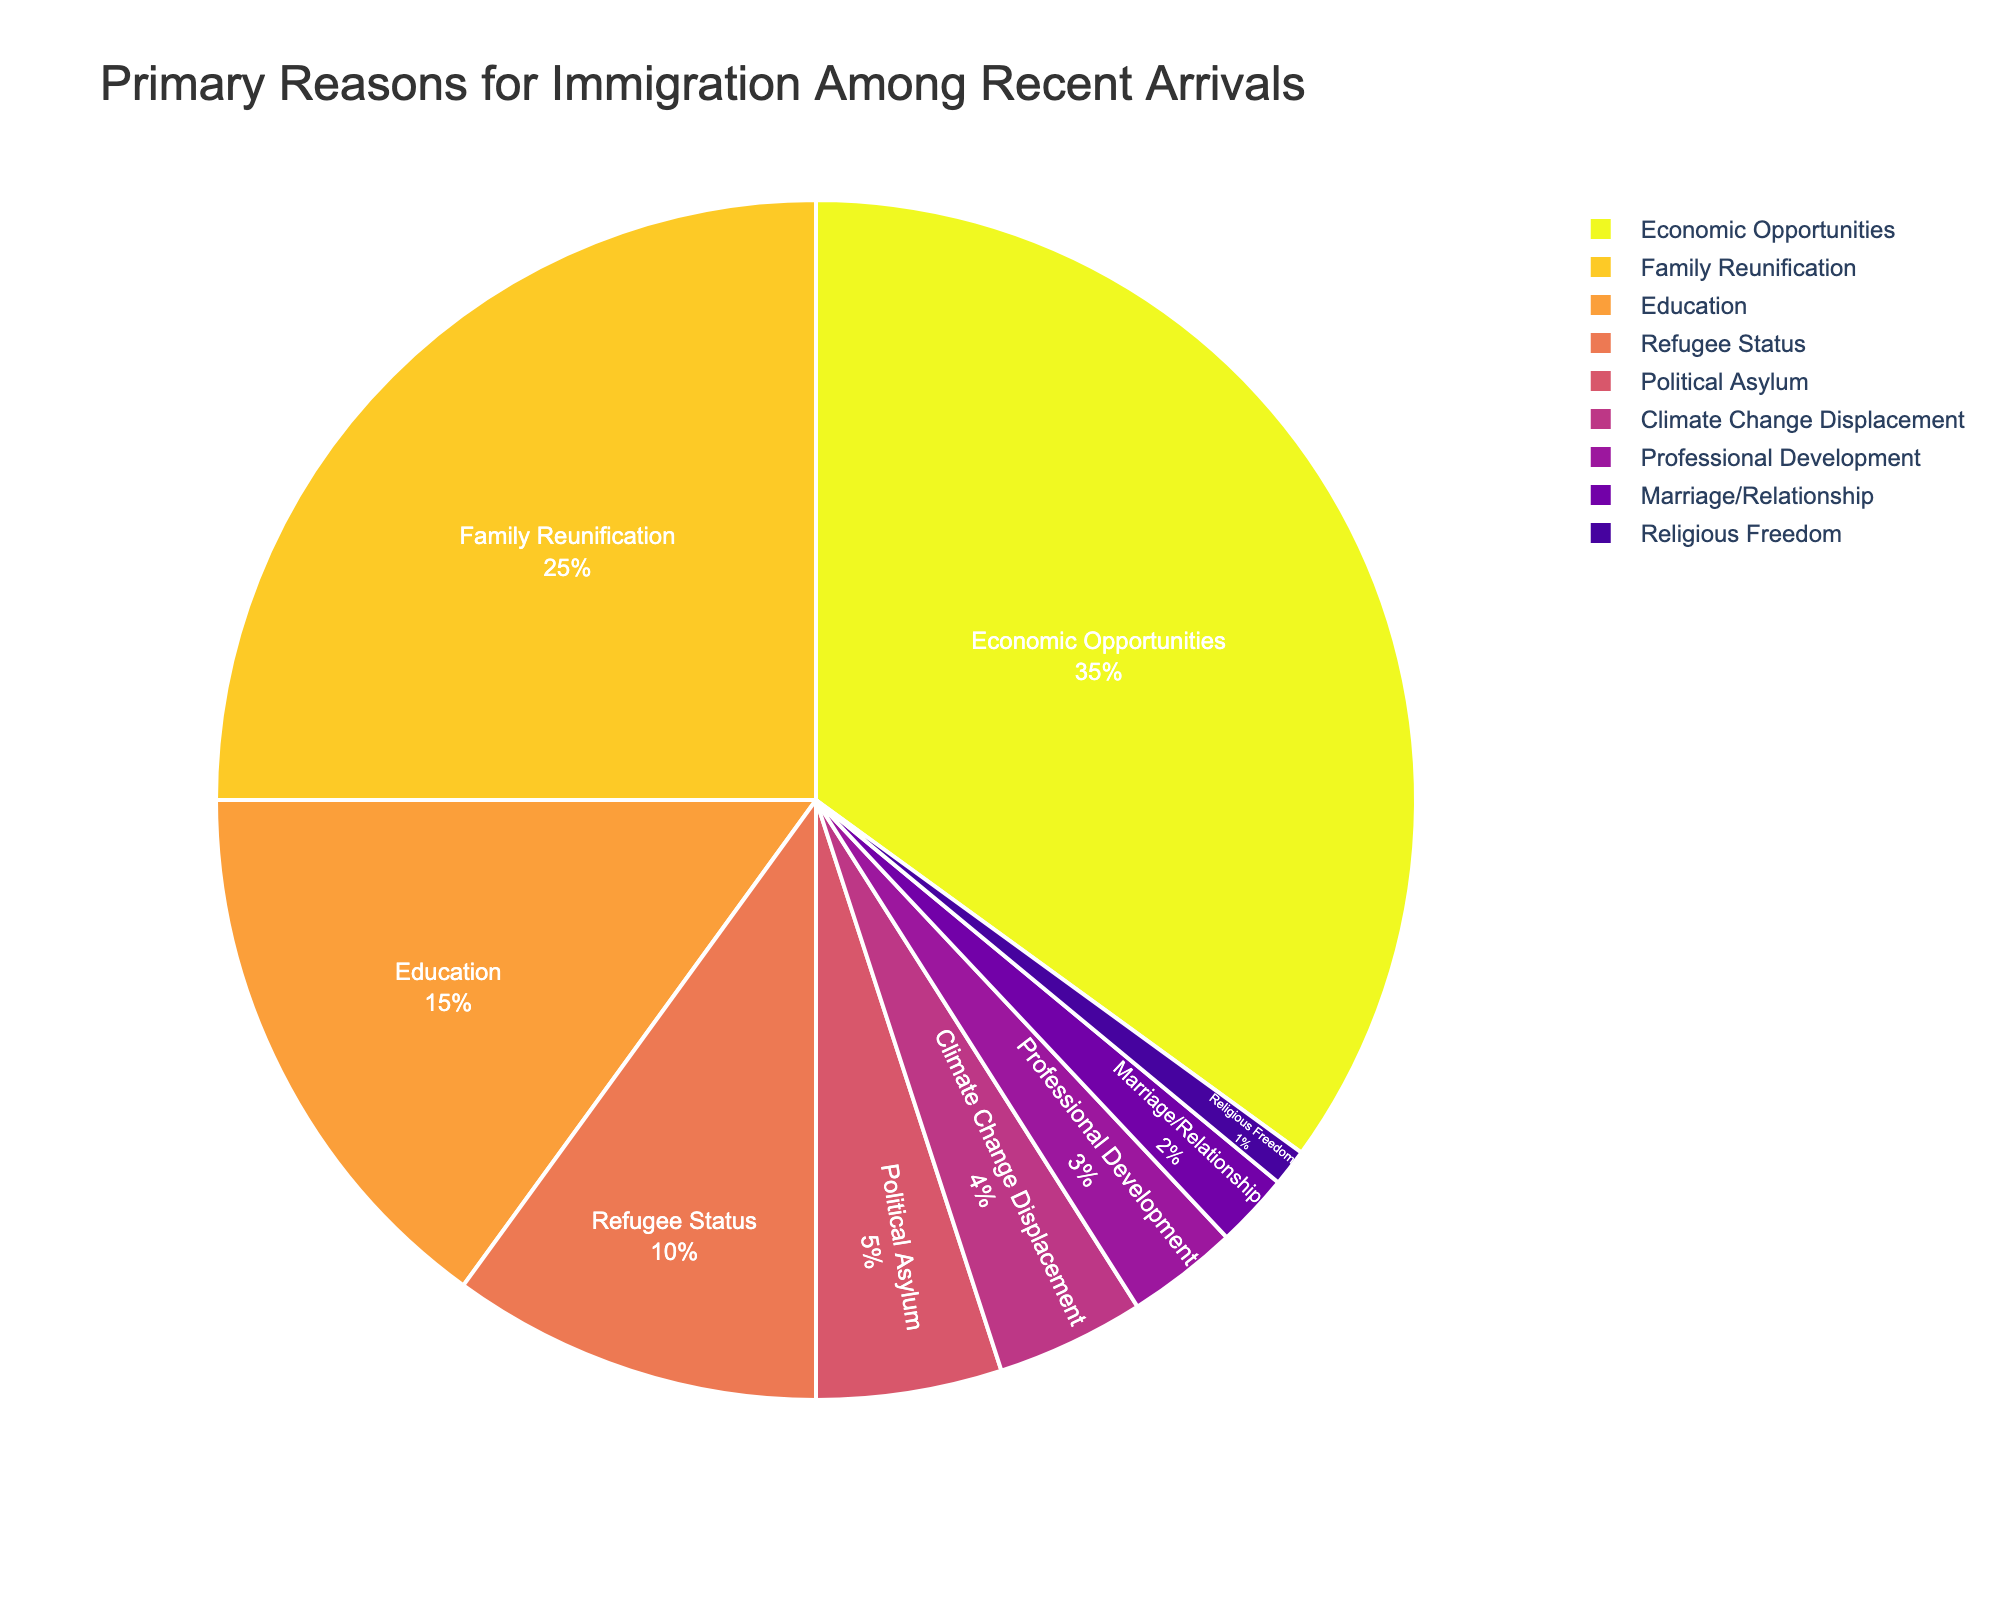What is the primary reason for immigration according to the pie chart? The largest slice of the pie chart represents the primary reason. "Economic Opportunities," which accounts for 35% of the total, is the largest slice.
Answer: Economic Opportunities Which category contributes more to immigration: Family Reunification or Refugee Status? Compare the percentages for both categories. "Family Reunification" is 25%, and "Refugee Status" is 10%. Since 25% is greater than 10%, Family Reunification contributes more.
Answer: Family Reunification What is the total percentage of immigrants arriving due to educational and professional reasons (Education and Professional Development)? Add the percentages of the "Education" and "Professional Development" slices: 15% + 3% = 18%.
Answer: 18% Which category has the smallest percentage representation and what is that percentage? The smallest slice in the pie chart represents "Religious Freedom" with 1% of the total.
Answer: Religious Freedom, 1% How much more significant is Economic Opportunities as a reason for immigration compared to Climate Change Displacement? Subtract the percentage of "Climate Change Displacement" (4%) from "Economic Opportunities" (35%): 35% - 4% = 31%.
Answer: 31% Which category is represented by a proportion visually similar to 10%? The slice labeled "Refugee Status" represents 10% of the total.
Answer: Refugee Status If the percentages of Family Reunification and Marriage/Relationship were combined, would they surpass Economic Opportunities? Combine percentages for "Family Reunification" (25%) and "Marriage/Relationship" (2%): 25% + 2% = 27%. Since 27% is less than 35%, they do not surpass Economic Opportunities.
Answer: No What is the percentage difference between Political Asylum and Marriage/Relationship? Subtract the percentage of "Marriage/Relationship" (2%) from "Political Asylum" (5%): 5% - 2% = 3%.
Answer: 3% How many percentage points does Family Reunification differ from Education? Subtract the percentage of "Education" (15%) from "Family Reunification" (25%): 25% - 15% = 10%.
Answer: 10% What is the combined percentage for all categories less than 5%? Add the percentages of "Climate Change Displacement" (4%), "Professional Development" (3%), "Marriage/Relationship" (2%), and "Religious Freedom" (1%): 4% + 3% + 2% + 1% = 10%.
Answer: 10% 